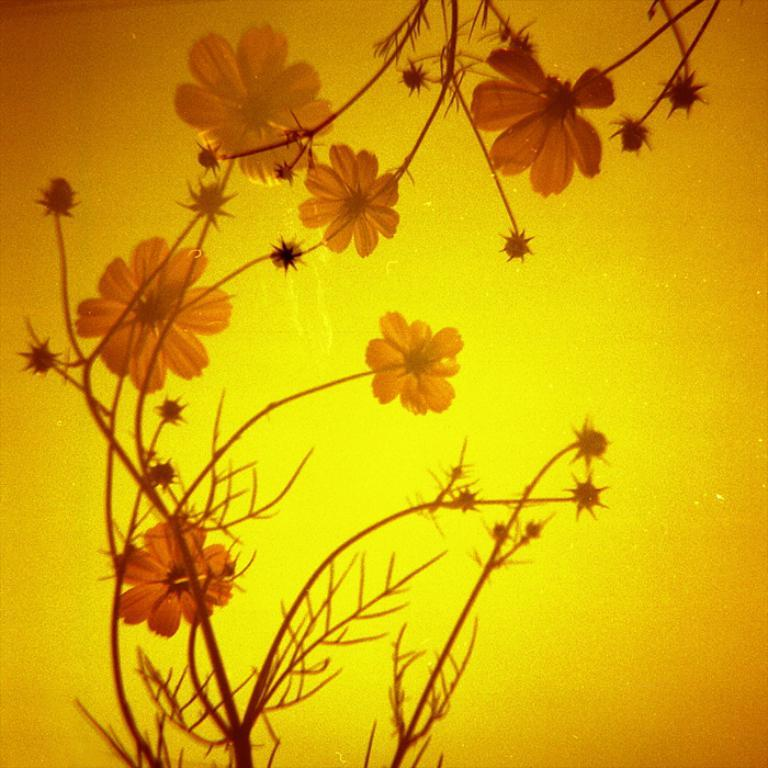What type of living organisms can be seen in the image? There are flowers on plants in the image. Can you describe the plants in the image? The plants in the image have flowers on them. What type of fuel is being used by the horn in the image? There is no fuel or horn present in the image; it features flowers on plants. 